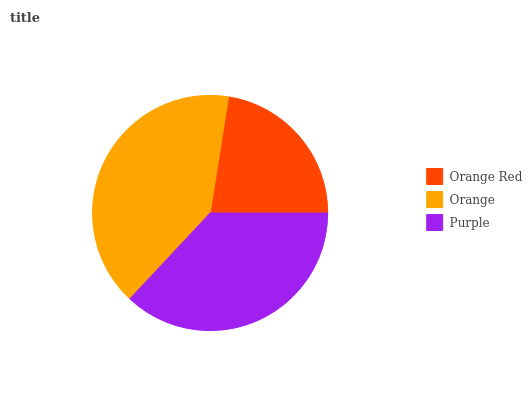Is Orange Red the minimum?
Answer yes or no. Yes. Is Orange the maximum?
Answer yes or no. Yes. Is Purple the minimum?
Answer yes or no. No. Is Purple the maximum?
Answer yes or no. No. Is Orange greater than Purple?
Answer yes or no. Yes. Is Purple less than Orange?
Answer yes or no. Yes. Is Purple greater than Orange?
Answer yes or no. No. Is Orange less than Purple?
Answer yes or no. No. Is Purple the high median?
Answer yes or no. Yes. Is Purple the low median?
Answer yes or no. Yes. Is Orange Red the high median?
Answer yes or no. No. Is Orange Red the low median?
Answer yes or no. No. 